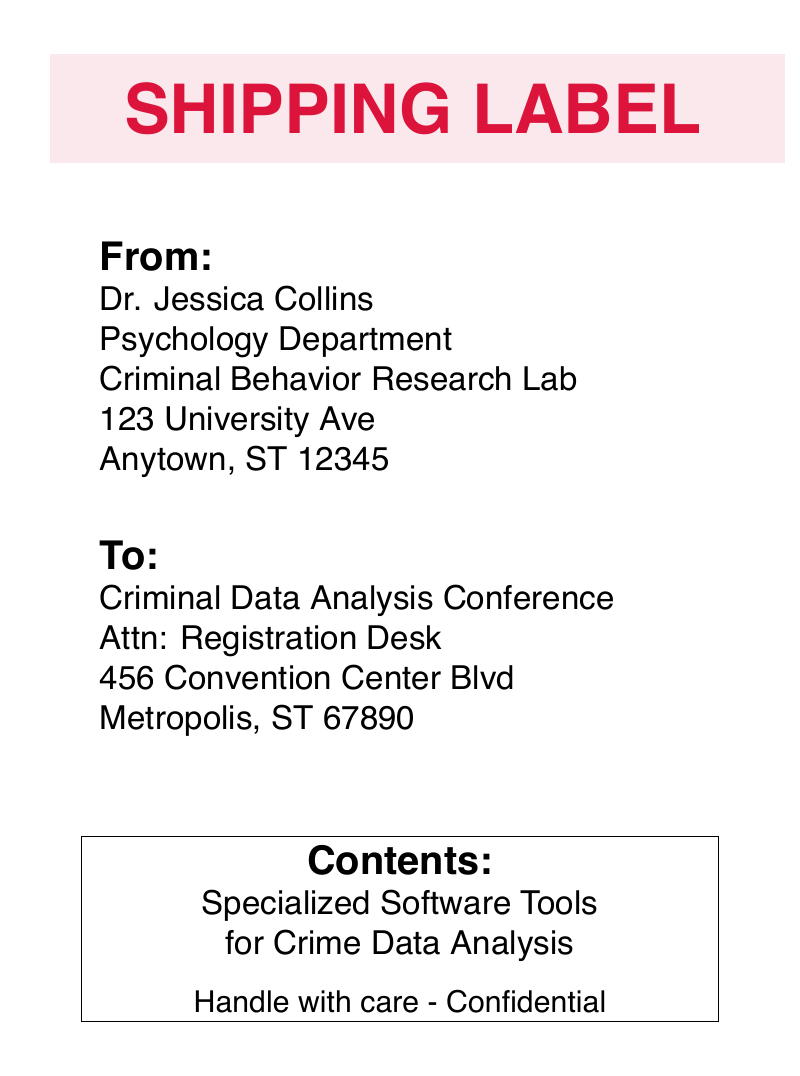What is the sender's name? The sender's name is provided in the "From" section of the document.
Answer: Dr. Jessica Collins What is the sender's department? The department is mentioned under the sender's name in the document.
Answer: Psychology Department What is the recipient's attention line? The attention line is stated in the "To" section of the document.
Answer: Registration Desk What city is the recipient located in? The city is given in the "To" section of the address for the recipient.
Answer: Metropolis What contents are included in the shipment? The contents are clearly outlined in the "Contents" section of the document.
Answer: Specialized Software Tools for Crime Data Analysis What should be noted about the contents? Special instructions regarding the handling of the contents are included in the document.
Answer: Handle with care - Confidential How should the materials be classified? The urgency level of the materials is highlighted in a specific section of the document.
Answer: URGENT What is the postal code of the sender's address? The postal code can be found at the end of the sender's address.
Answer: 12345 What is the postal code of the recipient's address? The postal code is located at the end of the recipient's address.
Answer: 67890 